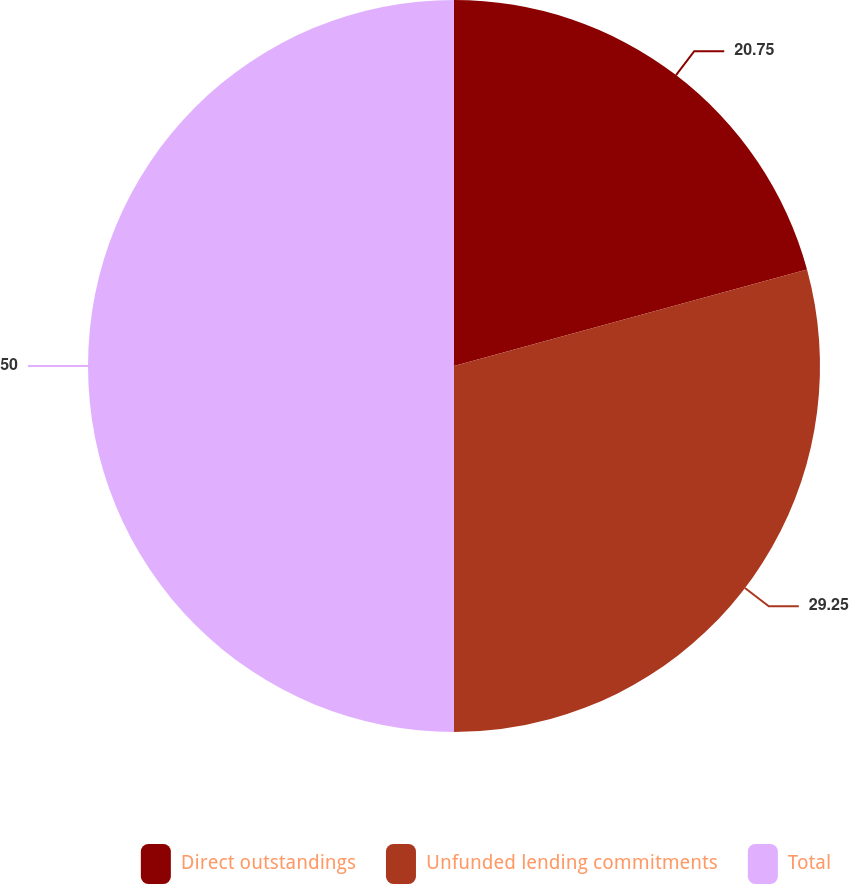Convert chart to OTSL. <chart><loc_0><loc_0><loc_500><loc_500><pie_chart><fcel>Direct outstandings<fcel>Unfunded lending commitments<fcel>Total<nl><fcel>20.75%<fcel>29.25%<fcel>50.0%<nl></chart> 